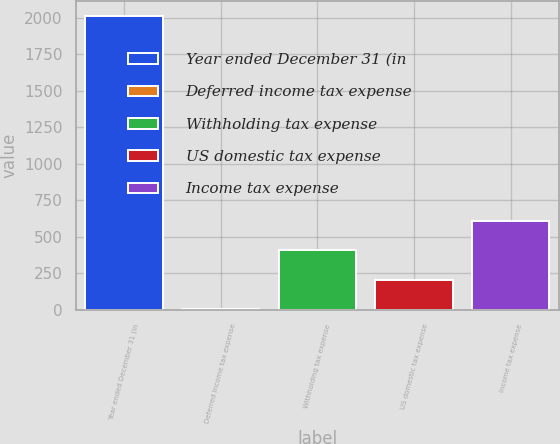Convert chart to OTSL. <chart><loc_0><loc_0><loc_500><loc_500><bar_chart><fcel>Year ended December 31 (in<fcel>Deferred income tax expense<fcel>Withholding tax expense<fcel>US domestic tax expense<fcel>Income tax expense<nl><fcel>2014<fcel>8<fcel>409.2<fcel>208.6<fcel>609.8<nl></chart> 